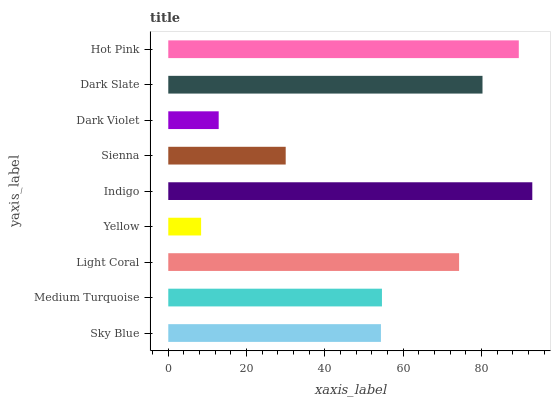Is Yellow the minimum?
Answer yes or no. Yes. Is Indigo the maximum?
Answer yes or no. Yes. Is Medium Turquoise the minimum?
Answer yes or no. No. Is Medium Turquoise the maximum?
Answer yes or no. No. Is Medium Turquoise greater than Sky Blue?
Answer yes or no. Yes. Is Sky Blue less than Medium Turquoise?
Answer yes or no. Yes. Is Sky Blue greater than Medium Turquoise?
Answer yes or no. No. Is Medium Turquoise less than Sky Blue?
Answer yes or no. No. Is Medium Turquoise the high median?
Answer yes or no. Yes. Is Medium Turquoise the low median?
Answer yes or no. Yes. Is Dark Violet the high median?
Answer yes or no. No. Is Light Coral the low median?
Answer yes or no. No. 